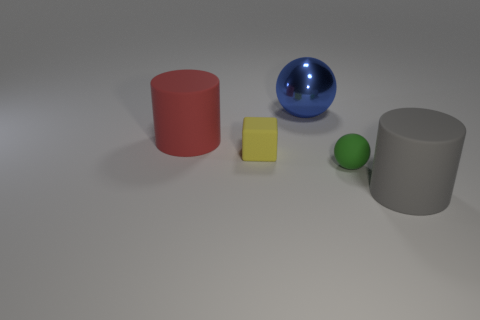Add 5 big gray matte cylinders. How many objects exist? 10 Subtract all blue spheres. How many spheres are left? 1 Subtract 1 balls. How many balls are left? 1 Subtract all red cylinders. Subtract all gray spheres. How many cylinders are left? 1 Subtract all brown balls. How many cyan cylinders are left? 0 Subtract all large metallic spheres. Subtract all balls. How many objects are left? 2 Add 5 large red matte cylinders. How many large red matte cylinders are left? 6 Add 3 red metallic objects. How many red metallic objects exist? 3 Subtract 1 gray cylinders. How many objects are left? 4 Subtract all cylinders. How many objects are left? 3 